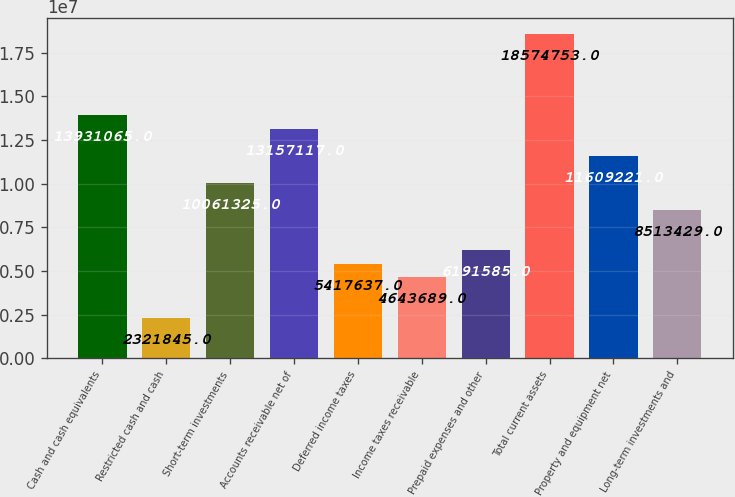Convert chart to OTSL. <chart><loc_0><loc_0><loc_500><loc_500><bar_chart><fcel>Cash and cash equivalents<fcel>Restricted cash and cash<fcel>Short-term investments<fcel>Accounts receivable net of<fcel>Deferred income taxes<fcel>Income taxes receivable<fcel>Prepaid expenses and other<fcel>Total current assets<fcel>Property and equipment net<fcel>Long-term investments and<nl><fcel>1.39311e+07<fcel>2.32184e+06<fcel>1.00613e+07<fcel>1.31571e+07<fcel>5.41764e+06<fcel>4.64369e+06<fcel>6.19158e+06<fcel>1.85748e+07<fcel>1.16092e+07<fcel>8.51343e+06<nl></chart> 